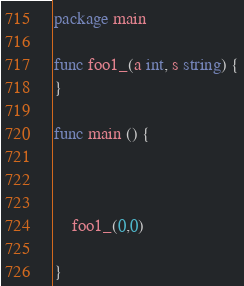<code> <loc_0><loc_0><loc_500><loc_500><_Go_>package main

func foo1_(a int, s string) {
}

func main () {



	foo1_(0,0)

}  
</code> 